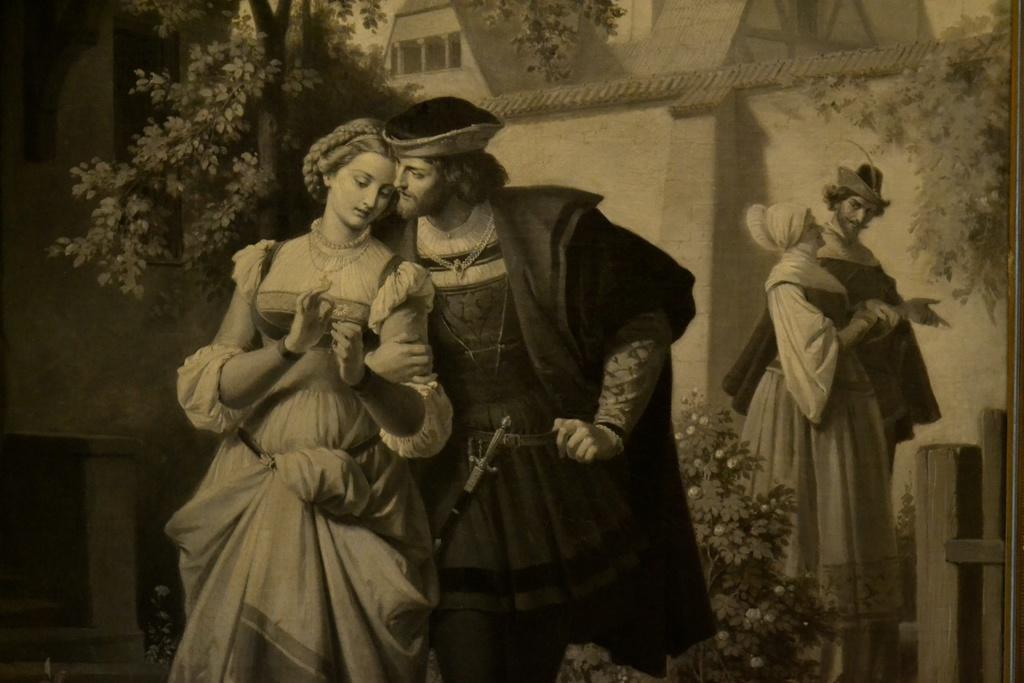Could you give a brief overview of what you see in this image? In this picture we can see painting, in the painting we can find few people, trees and houses. 